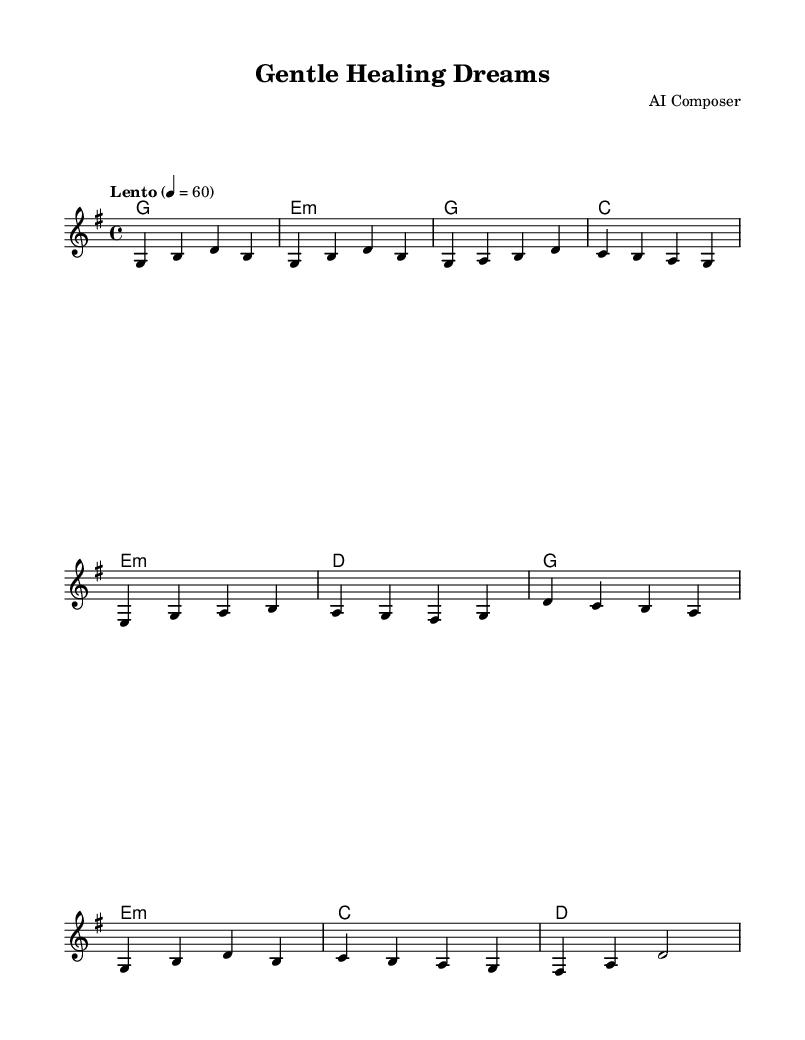What is the key signature of this music? The key signature of the music is G major, which has one sharp. This can be observed at the beginning of the sheet music where the key signature indicates a single sharp (F#).
Answer: G major What is the time signature of this music? The time signature is 4/4, which is indicated at the beginning of the score. This means there are four beats in each measure and the quarter note gets one beat.
Answer: 4/4 What is the tempo marking for this piece? The tempo marking is "Lento," which indicates a slow pace typically around 40-60 beats per minute. This informs the performer that the piece should be played slowly.
Answer: Lento How many measures are in the verse section? The verse section has four measures as indicated by the notation. It consists of a sequence of notes that are grouped into four distinct measures.
Answer: 4 What are the chord names used in the chorus? The chords used in the chorus are G, E minor, C, and D. These can be found in the chord mode section under the chorus line.
Answer: G, E minor, C, D Which instrument is primarily featured in this arrangement? The primary instrument featured in this arrangement is the guitar, as indicated by the named staff and the nature of the written music.
Answer: Guitar What is the last note of the chorus? The last note of the chorus is D. This can be found in the last measure of the chorus section where it is clearly notated.
Answer: D 